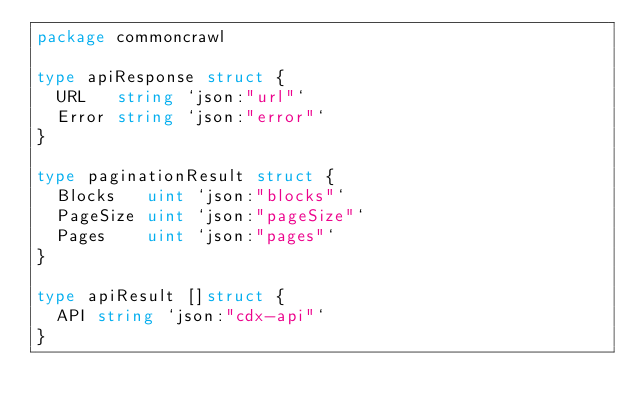<code> <loc_0><loc_0><loc_500><loc_500><_Go_>package commoncrawl

type apiResponse struct {
	URL   string `json:"url"`
	Error string `json:"error"`
}

type paginationResult struct {
	Blocks   uint `json:"blocks"`
	PageSize uint `json:"pageSize"`
	Pages    uint `json:"pages"`
}

type apiResult []struct {
	API string `json:"cdx-api"`
}
</code> 